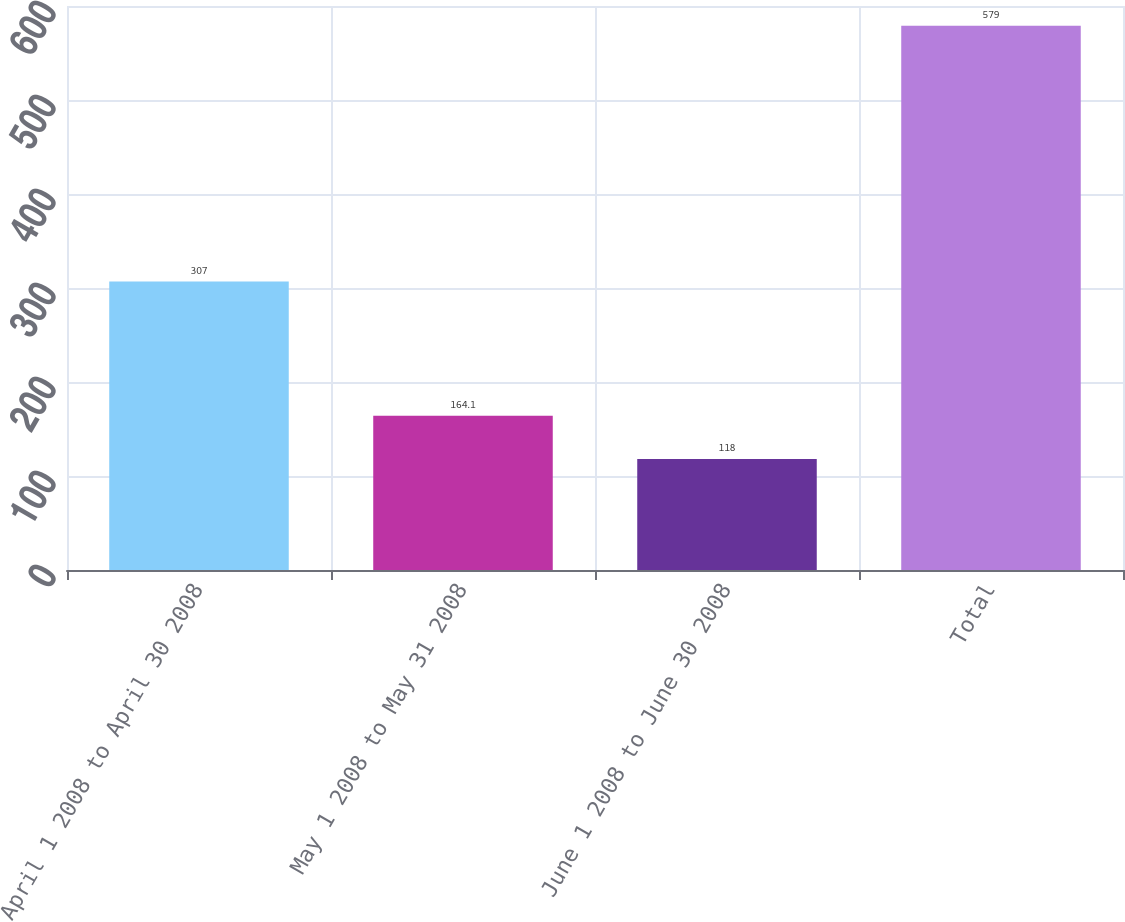Convert chart to OTSL. <chart><loc_0><loc_0><loc_500><loc_500><bar_chart><fcel>April 1 2008 to April 30 2008<fcel>May 1 2008 to May 31 2008<fcel>June 1 2008 to June 30 2008<fcel>Total<nl><fcel>307<fcel>164.1<fcel>118<fcel>579<nl></chart> 